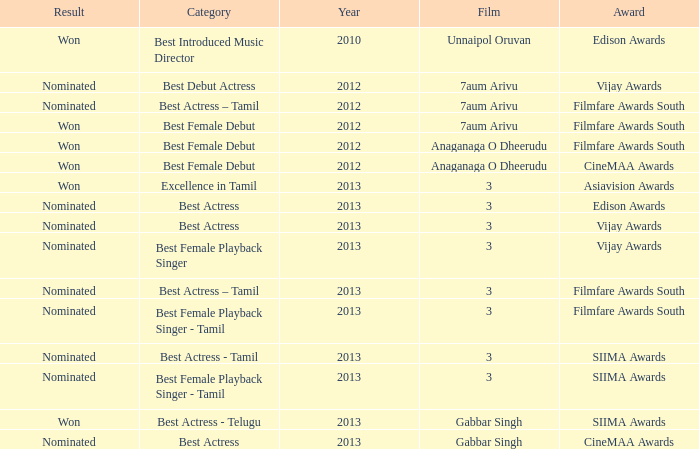What was the award for the excellence in tamil category? Asiavision Awards. 